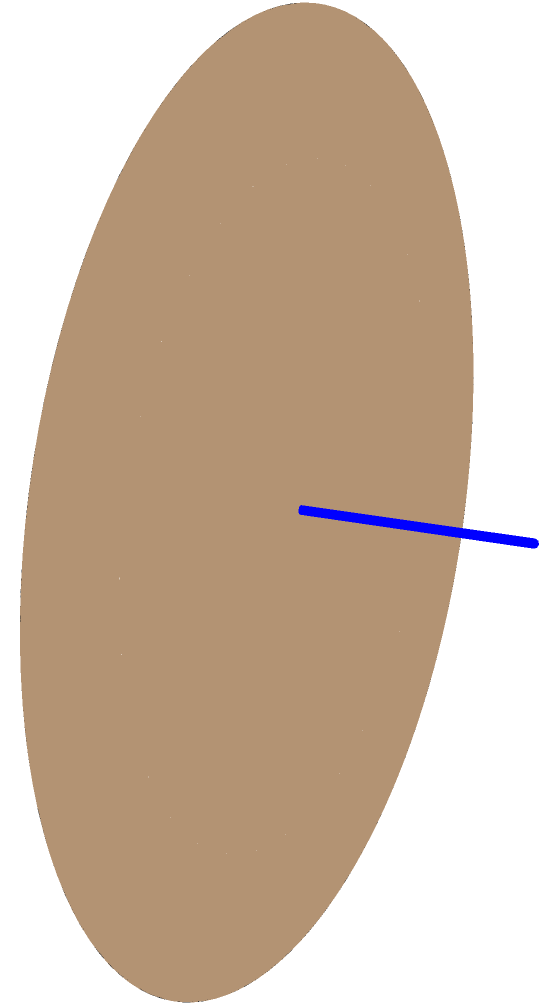Imagine a whimsical architectural marvel inspired by the enigmatic Möbius strip, where reality bends and twists like a dream caught in the throes of creation. This structure, a testament to the dance between mathematics and imagination, spans 20 meters in length and 5 meters in width. If we were to clothe this surreal edifice in a skin of shimmering titanium, how many square meters of this metallic canvas would we need to envelope our creation, allowing it to whisper its secrets to the cosmos? Let's unravel this architectural enigma step by step:

1) First, we must recognize that a Möbius strip has only one side and one edge. It's a portal to a dimension where inside and outside lose meaning.

2) The surface area of a Möbius strip is given by the formula:
   $$A = 2lw$$
   Where $l$ is the length and $w$ is the width of the strip before it's twisted and joined.

3) In our cosmic blueprint:
   $l = 20$ meters
   $w = 5$ meters

4) Let's paint our mathematical canvas:
   $$A = 2 \times 20 \times 5$$
   $$A = 2 \times 100$$
   $$A = 200$$

5) But wait! In the realm of architecture, we must account for imperfections and overlaps. Let's add a 10% allowance to our calculation:
   $$A_{final} = 200 \times 1.1 = 220$$

Thus, we need 220 square meters of titanium to cloak our Möbius-inspired masterpiece, allowing it to reflect the very fabric of space-time itself.
Answer: 220 square meters 